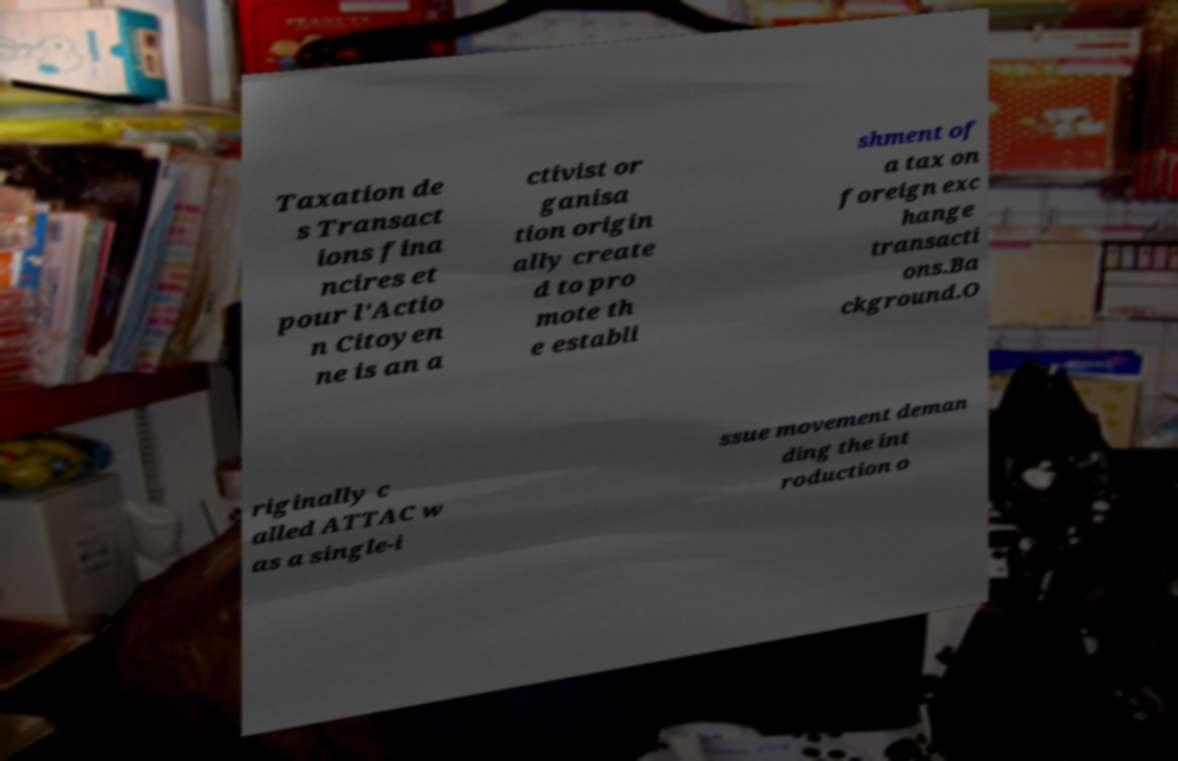What messages or text are displayed in this image? I need them in a readable, typed format. Taxation de s Transact ions fina ncires et pour l'Actio n Citoyen ne is an a ctivist or ganisa tion origin ally create d to pro mote th e establi shment of a tax on foreign exc hange transacti ons.Ba ckground.O riginally c alled ATTAC w as a single-i ssue movement deman ding the int roduction o 